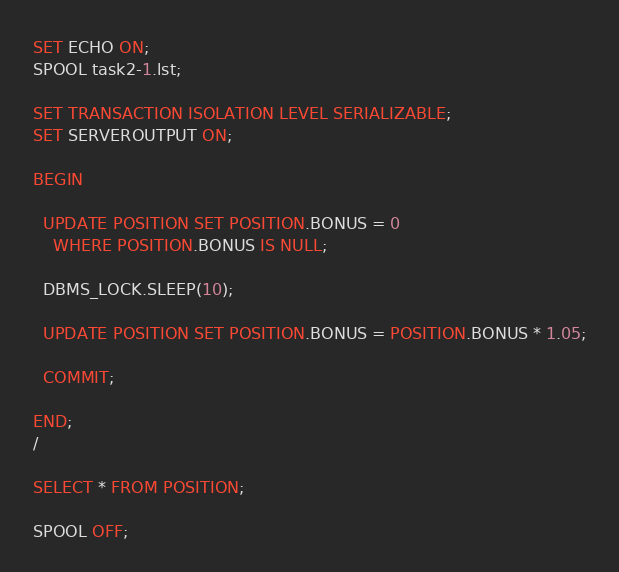Convert code to text. <code><loc_0><loc_0><loc_500><loc_500><_SQL_>SET ECHO ON;
SPOOL task2-1.lst;

SET TRANSACTION ISOLATION LEVEL SERIALIZABLE;
SET SERVEROUTPUT ON;

BEGIN
    
  UPDATE POSITION SET POSITION.BONUS = 0
    WHERE POSITION.BONUS IS NULL;
    
  DBMS_LOCK.SLEEP(10);
    
  UPDATE POSITION SET POSITION.BONUS = POSITION.BONUS * 1.05;

  COMMIT;

END;
/

SELECT * FROM POSITION;

SPOOL OFF;
</code> 